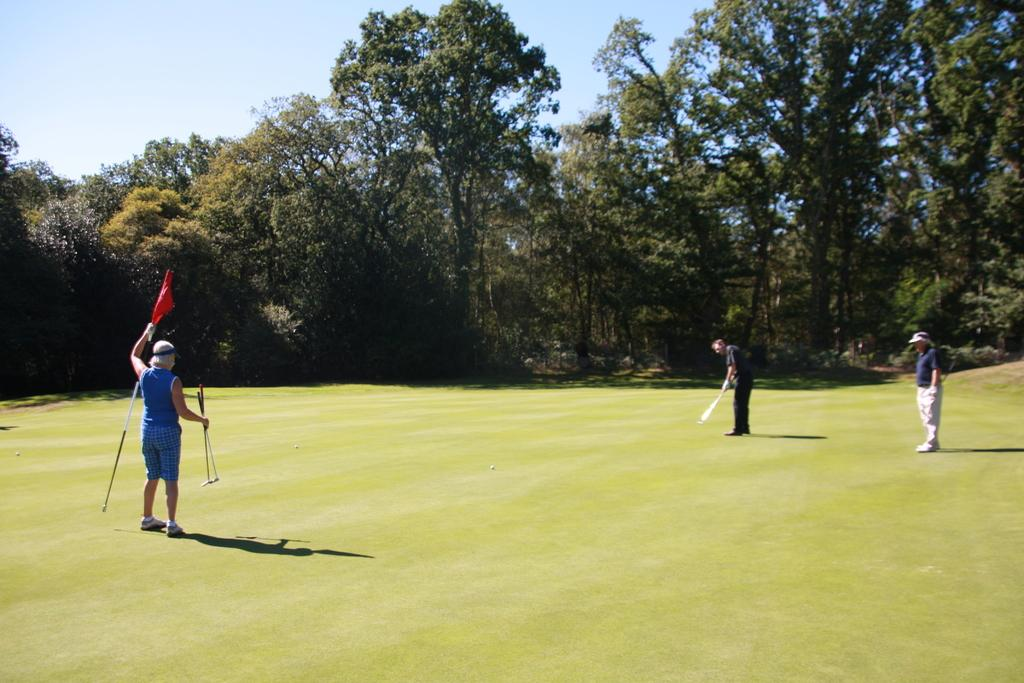What is happening in the image? There are people standing in the image. What can be seen in the background of the image? There are trees in the background of the image. What is visible above the people in the image? The sky is visible in the image. What type of ground surface is present at the bottom of the image? There is grass at the bottom of the image. How many balls are being pushed by the people in the image? There are no balls present in the image, and the people are not pushing anything. 